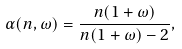<formula> <loc_0><loc_0><loc_500><loc_500>\alpha ( n , \omega ) = \frac { n ( 1 + \omega ) } { n ( 1 + \omega ) - 2 } ,</formula> 